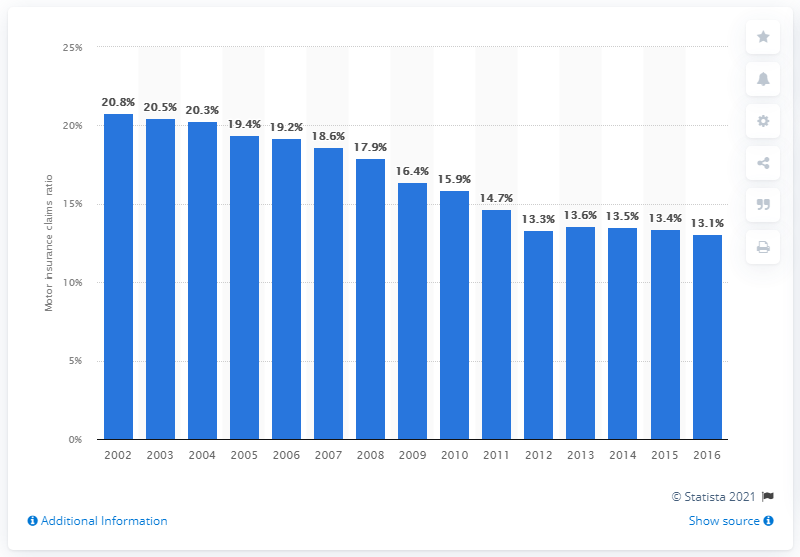Outline some significant characteristics in this image. The total motor claims frequency in 2002 was 20.8. The total frequency of motor claims is 20.8. 